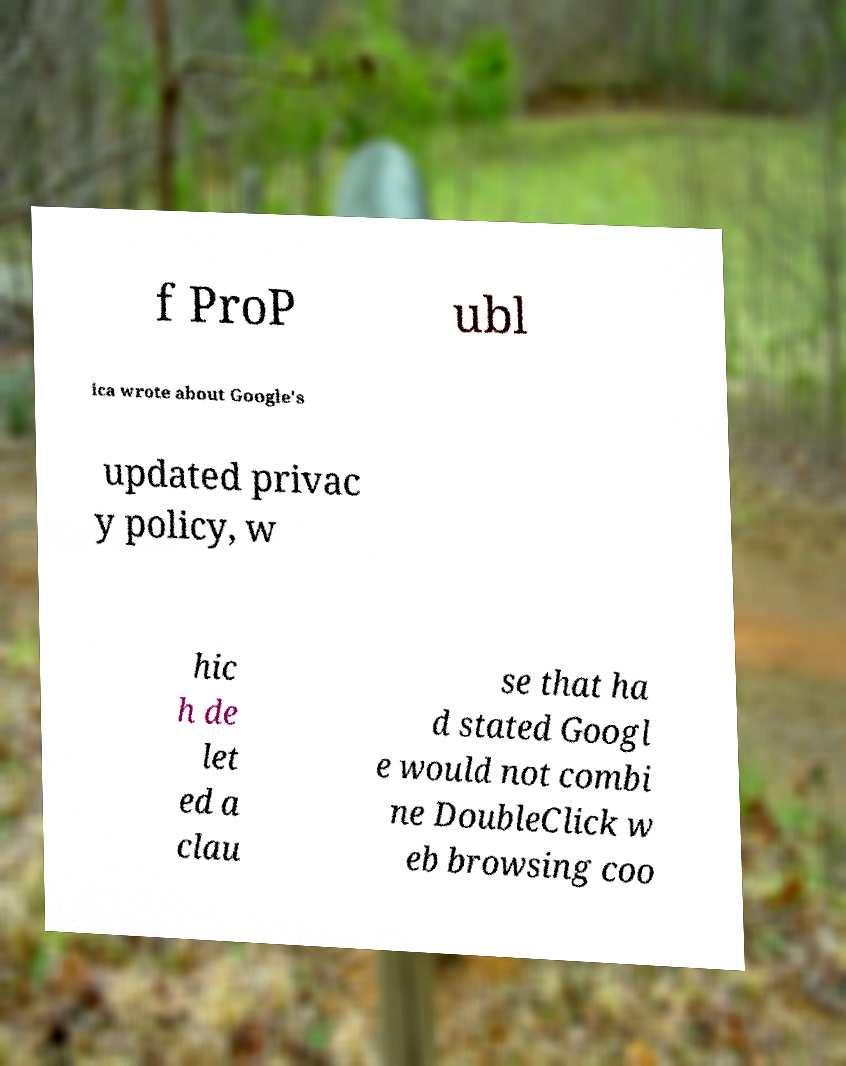Can you accurately transcribe the text from the provided image for me? f ProP ubl ica wrote about Google's updated privac y policy, w hic h de let ed a clau se that ha d stated Googl e would not combi ne DoubleClick w eb browsing coo 